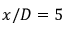<formula> <loc_0><loc_0><loc_500><loc_500>x / D = 5</formula> 